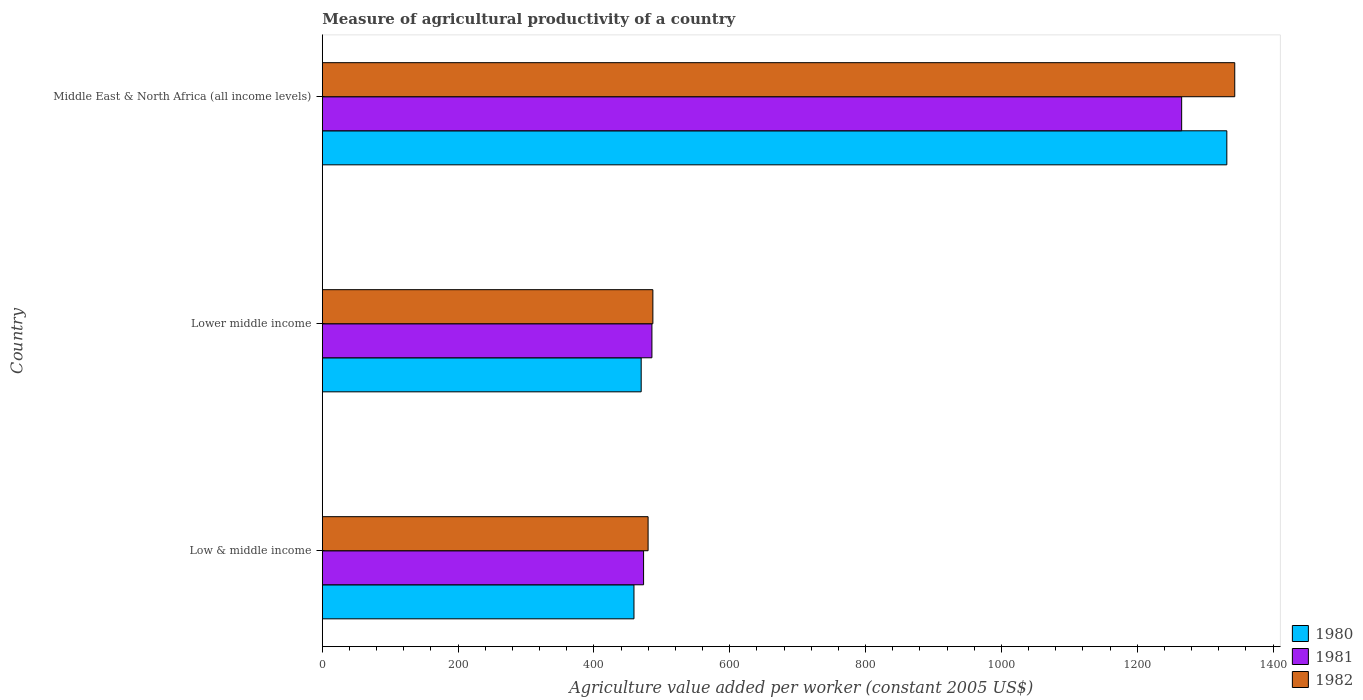How many groups of bars are there?
Offer a very short reply. 3. Are the number of bars per tick equal to the number of legend labels?
Keep it short and to the point. Yes. How many bars are there on the 1st tick from the top?
Keep it short and to the point. 3. How many bars are there on the 3rd tick from the bottom?
Give a very brief answer. 3. What is the label of the 2nd group of bars from the top?
Your answer should be compact. Lower middle income. In how many cases, is the number of bars for a given country not equal to the number of legend labels?
Offer a terse response. 0. What is the measure of agricultural productivity in 1982 in Middle East & North Africa (all income levels)?
Provide a succinct answer. 1343.53. Across all countries, what is the maximum measure of agricultural productivity in 1980?
Provide a succinct answer. 1331.86. Across all countries, what is the minimum measure of agricultural productivity in 1980?
Provide a succinct answer. 458.89. In which country was the measure of agricultural productivity in 1982 maximum?
Your answer should be very brief. Middle East & North Africa (all income levels). In which country was the measure of agricultural productivity in 1981 minimum?
Ensure brevity in your answer.  Low & middle income. What is the total measure of agricultural productivity in 1980 in the graph?
Your answer should be compact. 2260.27. What is the difference between the measure of agricultural productivity in 1982 in Low & middle income and that in Lower middle income?
Offer a very short reply. -7.05. What is the difference between the measure of agricultural productivity in 1980 in Lower middle income and the measure of agricultural productivity in 1982 in Low & middle income?
Offer a terse response. -10.18. What is the average measure of agricultural productivity in 1982 per country?
Give a very brief answer. 769.99. What is the difference between the measure of agricultural productivity in 1981 and measure of agricultural productivity in 1982 in Middle East & North Africa (all income levels)?
Your answer should be compact. -78.18. What is the ratio of the measure of agricultural productivity in 1982 in Lower middle income to that in Middle East & North Africa (all income levels)?
Ensure brevity in your answer.  0.36. What is the difference between the highest and the second highest measure of agricultural productivity in 1980?
Provide a succinct answer. 862.35. What is the difference between the highest and the lowest measure of agricultural productivity in 1982?
Ensure brevity in your answer.  863.84. In how many countries, is the measure of agricultural productivity in 1980 greater than the average measure of agricultural productivity in 1980 taken over all countries?
Ensure brevity in your answer.  1. Is the sum of the measure of agricultural productivity in 1981 in Low & middle income and Lower middle income greater than the maximum measure of agricultural productivity in 1982 across all countries?
Make the answer very short. No. What does the 3rd bar from the bottom in Lower middle income represents?
Make the answer very short. 1982. Are all the bars in the graph horizontal?
Make the answer very short. Yes. What is the difference between two consecutive major ticks on the X-axis?
Make the answer very short. 200. Does the graph contain any zero values?
Provide a succinct answer. No. Does the graph contain grids?
Provide a succinct answer. No. How many legend labels are there?
Give a very brief answer. 3. What is the title of the graph?
Your response must be concise. Measure of agricultural productivity of a country. Does "1996" appear as one of the legend labels in the graph?
Ensure brevity in your answer.  No. What is the label or title of the X-axis?
Make the answer very short. Agriculture value added per worker (constant 2005 US$). What is the label or title of the Y-axis?
Your answer should be very brief. Country. What is the Agriculture value added per worker (constant 2005 US$) of 1980 in Low & middle income?
Your answer should be very brief. 458.89. What is the Agriculture value added per worker (constant 2005 US$) of 1981 in Low & middle income?
Keep it short and to the point. 473.04. What is the Agriculture value added per worker (constant 2005 US$) in 1982 in Low & middle income?
Keep it short and to the point. 479.69. What is the Agriculture value added per worker (constant 2005 US$) in 1980 in Lower middle income?
Ensure brevity in your answer.  469.51. What is the Agriculture value added per worker (constant 2005 US$) in 1981 in Lower middle income?
Your answer should be very brief. 485.33. What is the Agriculture value added per worker (constant 2005 US$) of 1982 in Lower middle income?
Ensure brevity in your answer.  486.74. What is the Agriculture value added per worker (constant 2005 US$) of 1980 in Middle East & North Africa (all income levels)?
Your answer should be compact. 1331.86. What is the Agriculture value added per worker (constant 2005 US$) of 1981 in Middle East & North Africa (all income levels)?
Your answer should be very brief. 1265.35. What is the Agriculture value added per worker (constant 2005 US$) in 1982 in Middle East & North Africa (all income levels)?
Your answer should be very brief. 1343.53. Across all countries, what is the maximum Agriculture value added per worker (constant 2005 US$) of 1980?
Ensure brevity in your answer.  1331.86. Across all countries, what is the maximum Agriculture value added per worker (constant 2005 US$) in 1981?
Your response must be concise. 1265.35. Across all countries, what is the maximum Agriculture value added per worker (constant 2005 US$) of 1982?
Offer a very short reply. 1343.53. Across all countries, what is the minimum Agriculture value added per worker (constant 2005 US$) of 1980?
Provide a succinct answer. 458.89. Across all countries, what is the minimum Agriculture value added per worker (constant 2005 US$) of 1981?
Your response must be concise. 473.04. Across all countries, what is the minimum Agriculture value added per worker (constant 2005 US$) in 1982?
Provide a short and direct response. 479.69. What is the total Agriculture value added per worker (constant 2005 US$) of 1980 in the graph?
Give a very brief answer. 2260.27. What is the total Agriculture value added per worker (constant 2005 US$) of 1981 in the graph?
Keep it short and to the point. 2223.73. What is the total Agriculture value added per worker (constant 2005 US$) of 1982 in the graph?
Ensure brevity in your answer.  2309.96. What is the difference between the Agriculture value added per worker (constant 2005 US$) in 1980 in Low & middle income and that in Lower middle income?
Offer a terse response. -10.62. What is the difference between the Agriculture value added per worker (constant 2005 US$) in 1981 in Low & middle income and that in Lower middle income?
Offer a very short reply. -12.29. What is the difference between the Agriculture value added per worker (constant 2005 US$) in 1982 in Low & middle income and that in Lower middle income?
Provide a short and direct response. -7.05. What is the difference between the Agriculture value added per worker (constant 2005 US$) in 1980 in Low & middle income and that in Middle East & North Africa (all income levels)?
Offer a terse response. -872.97. What is the difference between the Agriculture value added per worker (constant 2005 US$) in 1981 in Low & middle income and that in Middle East & North Africa (all income levels)?
Offer a very short reply. -792.31. What is the difference between the Agriculture value added per worker (constant 2005 US$) of 1982 in Low & middle income and that in Middle East & North Africa (all income levels)?
Make the answer very short. -863.84. What is the difference between the Agriculture value added per worker (constant 2005 US$) of 1980 in Lower middle income and that in Middle East & North Africa (all income levels)?
Provide a short and direct response. -862.35. What is the difference between the Agriculture value added per worker (constant 2005 US$) in 1981 in Lower middle income and that in Middle East & North Africa (all income levels)?
Make the answer very short. -780.02. What is the difference between the Agriculture value added per worker (constant 2005 US$) in 1982 in Lower middle income and that in Middle East & North Africa (all income levels)?
Provide a succinct answer. -856.79. What is the difference between the Agriculture value added per worker (constant 2005 US$) in 1980 in Low & middle income and the Agriculture value added per worker (constant 2005 US$) in 1981 in Lower middle income?
Offer a very short reply. -26.44. What is the difference between the Agriculture value added per worker (constant 2005 US$) of 1980 in Low & middle income and the Agriculture value added per worker (constant 2005 US$) of 1982 in Lower middle income?
Your answer should be compact. -27.85. What is the difference between the Agriculture value added per worker (constant 2005 US$) in 1981 in Low & middle income and the Agriculture value added per worker (constant 2005 US$) in 1982 in Lower middle income?
Your answer should be very brief. -13.7. What is the difference between the Agriculture value added per worker (constant 2005 US$) of 1980 in Low & middle income and the Agriculture value added per worker (constant 2005 US$) of 1981 in Middle East & North Africa (all income levels)?
Your response must be concise. -806.46. What is the difference between the Agriculture value added per worker (constant 2005 US$) in 1980 in Low & middle income and the Agriculture value added per worker (constant 2005 US$) in 1982 in Middle East & North Africa (all income levels)?
Offer a terse response. -884.64. What is the difference between the Agriculture value added per worker (constant 2005 US$) in 1981 in Low & middle income and the Agriculture value added per worker (constant 2005 US$) in 1982 in Middle East & North Africa (all income levels)?
Keep it short and to the point. -870.49. What is the difference between the Agriculture value added per worker (constant 2005 US$) of 1980 in Lower middle income and the Agriculture value added per worker (constant 2005 US$) of 1981 in Middle East & North Africa (all income levels)?
Your answer should be very brief. -795.84. What is the difference between the Agriculture value added per worker (constant 2005 US$) of 1980 in Lower middle income and the Agriculture value added per worker (constant 2005 US$) of 1982 in Middle East & North Africa (all income levels)?
Keep it short and to the point. -874.02. What is the difference between the Agriculture value added per worker (constant 2005 US$) in 1981 in Lower middle income and the Agriculture value added per worker (constant 2005 US$) in 1982 in Middle East & North Africa (all income levels)?
Give a very brief answer. -858.2. What is the average Agriculture value added per worker (constant 2005 US$) of 1980 per country?
Give a very brief answer. 753.42. What is the average Agriculture value added per worker (constant 2005 US$) in 1981 per country?
Provide a succinct answer. 741.24. What is the average Agriculture value added per worker (constant 2005 US$) in 1982 per country?
Offer a terse response. 769.99. What is the difference between the Agriculture value added per worker (constant 2005 US$) in 1980 and Agriculture value added per worker (constant 2005 US$) in 1981 in Low & middle income?
Offer a terse response. -14.15. What is the difference between the Agriculture value added per worker (constant 2005 US$) of 1980 and Agriculture value added per worker (constant 2005 US$) of 1982 in Low & middle income?
Offer a terse response. -20.8. What is the difference between the Agriculture value added per worker (constant 2005 US$) of 1981 and Agriculture value added per worker (constant 2005 US$) of 1982 in Low & middle income?
Provide a short and direct response. -6.65. What is the difference between the Agriculture value added per worker (constant 2005 US$) in 1980 and Agriculture value added per worker (constant 2005 US$) in 1981 in Lower middle income?
Your answer should be compact. -15.82. What is the difference between the Agriculture value added per worker (constant 2005 US$) of 1980 and Agriculture value added per worker (constant 2005 US$) of 1982 in Lower middle income?
Your answer should be compact. -17.23. What is the difference between the Agriculture value added per worker (constant 2005 US$) of 1981 and Agriculture value added per worker (constant 2005 US$) of 1982 in Lower middle income?
Make the answer very short. -1.4. What is the difference between the Agriculture value added per worker (constant 2005 US$) of 1980 and Agriculture value added per worker (constant 2005 US$) of 1981 in Middle East & North Africa (all income levels)?
Ensure brevity in your answer.  66.51. What is the difference between the Agriculture value added per worker (constant 2005 US$) in 1980 and Agriculture value added per worker (constant 2005 US$) in 1982 in Middle East & North Africa (all income levels)?
Your response must be concise. -11.67. What is the difference between the Agriculture value added per worker (constant 2005 US$) in 1981 and Agriculture value added per worker (constant 2005 US$) in 1982 in Middle East & North Africa (all income levels)?
Keep it short and to the point. -78.18. What is the ratio of the Agriculture value added per worker (constant 2005 US$) of 1980 in Low & middle income to that in Lower middle income?
Your answer should be very brief. 0.98. What is the ratio of the Agriculture value added per worker (constant 2005 US$) of 1981 in Low & middle income to that in Lower middle income?
Make the answer very short. 0.97. What is the ratio of the Agriculture value added per worker (constant 2005 US$) in 1982 in Low & middle income to that in Lower middle income?
Provide a short and direct response. 0.99. What is the ratio of the Agriculture value added per worker (constant 2005 US$) of 1980 in Low & middle income to that in Middle East & North Africa (all income levels)?
Make the answer very short. 0.34. What is the ratio of the Agriculture value added per worker (constant 2005 US$) in 1981 in Low & middle income to that in Middle East & North Africa (all income levels)?
Give a very brief answer. 0.37. What is the ratio of the Agriculture value added per worker (constant 2005 US$) in 1982 in Low & middle income to that in Middle East & North Africa (all income levels)?
Provide a short and direct response. 0.36. What is the ratio of the Agriculture value added per worker (constant 2005 US$) of 1980 in Lower middle income to that in Middle East & North Africa (all income levels)?
Give a very brief answer. 0.35. What is the ratio of the Agriculture value added per worker (constant 2005 US$) of 1981 in Lower middle income to that in Middle East & North Africa (all income levels)?
Your answer should be compact. 0.38. What is the ratio of the Agriculture value added per worker (constant 2005 US$) of 1982 in Lower middle income to that in Middle East & North Africa (all income levels)?
Offer a terse response. 0.36. What is the difference between the highest and the second highest Agriculture value added per worker (constant 2005 US$) of 1980?
Make the answer very short. 862.35. What is the difference between the highest and the second highest Agriculture value added per worker (constant 2005 US$) of 1981?
Give a very brief answer. 780.02. What is the difference between the highest and the second highest Agriculture value added per worker (constant 2005 US$) of 1982?
Provide a succinct answer. 856.79. What is the difference between the highest and the lowest Agriculture value added per worker (constant 2005 US$) of 1980?
Keep it short and to the point. 872.97. What is the difference between the highest and the lowest Agriculture value added per worker (constant 2005 US$) of 1981?
Your answer should be very brief. 792.31. What is the difference between the highest and the lowest Agriculture value added per worker (constant 2005 US$) of 1982?
Offer a very short reply. 863.84. 